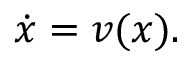Convert formula to latex. <formula><loc_0><loc_0><loc_500><loc_500>{ \dot { x } } = v ( x ) .</formula> 